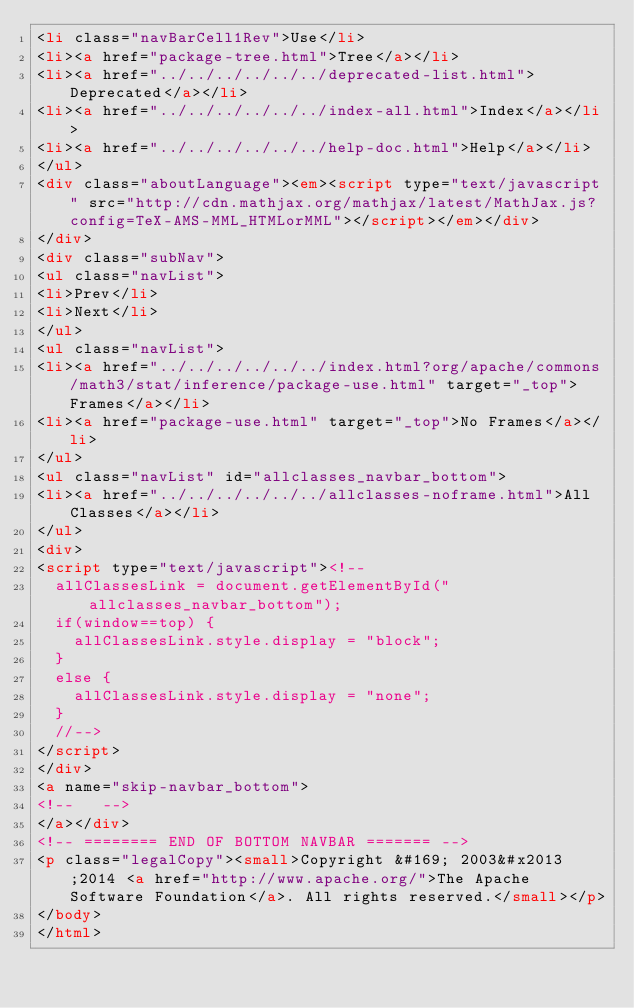<code> <loc_0><loc_0><loc_500><loc_500><_HTML_><li class="navBarCell1Rev">Use</li>
<li><a href="package-tree.html">Tree</a></li>
<li><a href="../../../../../../deprecated-list.html">Deprecated</a></li>
<li><a href="../../../../../../index-all.html">Index</a></li>
<li><a href="../../../../../../help-doc.html">Help</a></li>
</ul>
<div class="aboutLanguage"><em><script type="text/javascript" src="http://cdn.mathjax.org/mathjax/latest/MathJax.js?config=TeX-AMS-MML_HTMLorMML"></script></em></div>
</div>
<div class="subNav">
<ul class="navList">
<li>Prev</li>
<li>Next</li>
</ul>
<ul class="navList">
<li><a href="../../../../../../index.html?org/apache/commons/math3/stat/inference/package-use.html" target="_top">Frames</a></li>
<li><a href="package-use.html" target="_top">No Frames</a></li>
</ul>
<ul class="navList" id="allclasses_navbar_bottom">
<li><a href="../../../../../../allclasses-noframe.html">All Classes</a></li>
</ul>
<div>
<script type="text/javascript"><!--
  allClassesLink = document.getElementById("allclasses_navbar_bottom");
  if(window==top) {
    allClassesLink.style.display = "block";
  }
  else {
    allClassesLink.style.display = "none";
  }
  //-->
</script>
</div>
<a name="skip-navbar_bottom">
<!--   -->
</a></div>
<!-- ======== END OF BOTTOM NAVBAR ======= -->
<p class="legalCopy"><small>Copyright &#169; 2003&#x2013;2014 <a href="http://www.apache.org/">The Apache Software Foundation</a>. All rights reserved.</small></p>
</body>
</html>
</code> 